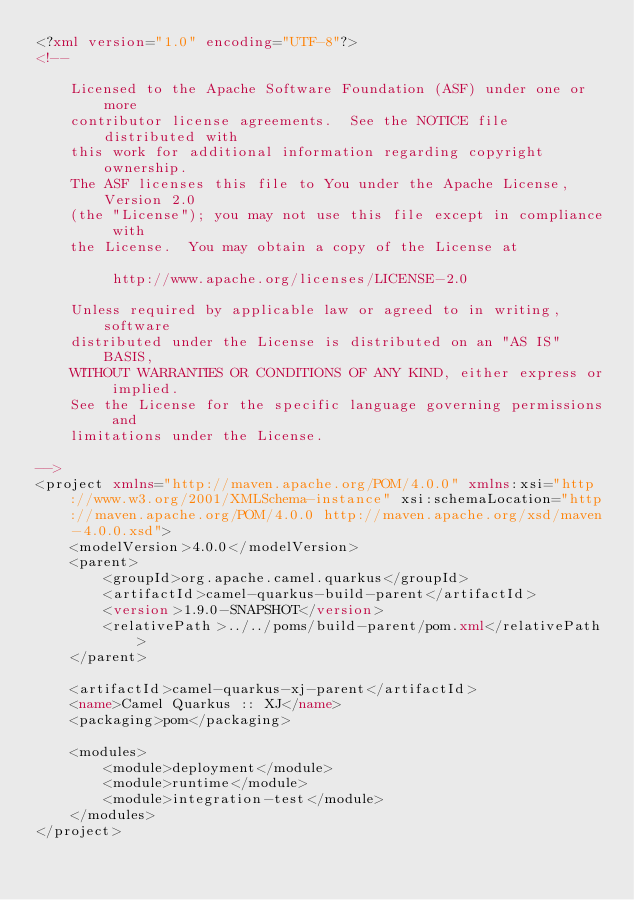Convert code to text. <code><loc_0><loc_0><loc_500><loc_500><_XML_><?xml version="1.0" encoding="UTF-8"?>
<!--

    Licensed to the Apache Software Foundation (ASF) under one or more
    contributor license agreements.  See the NOTICE file distributed with
    this work for additional information regarding copyright ownership.
    The ASF licenses this file to You under the Apache License, Version 2.0
    (the "License"); you may not use this file except in compliance with
    the License.  You may obtain a copy of the License at

         http://www.apache.org/licenses/LICENSE-2.0

    Unless required by applicable law or agreed to in writing, software
    distributed under the License is distributed on an "AS IS" BASIS,
    WITHOUT WARRANTIES OR CONDITIONS OF ANY KIND, either express or implied.
    See the License for the specific language governing permissions and
    limitations under the License.

-->
<project xmlns="http://maven.apache.org/POM/4.0.0" xmlns:xsi="http://www.w3.org/2001/XMLSchema-instance" xsi:schemaLocation="http://maven.apache.org/POM/4.0.0 http://maven.apache.org/xsd/maven-4.0.0.xsd">
    <modelVersion>4.0.0</modelVersion>
    <parent>
        <groupId>org.apache.camel.quarkus</groupId>
        <artifactId>camel-quarkus-build-parent</artifactId>
        <version>1.9.0-SNAPSHOT</version>
        <relativePath>../../poms/build-parent/pom.xml</relativePath>
    </parent>

    <artifactId>camel-quarkus-xj-parent</artifactId>
    <name>Camel Quarkus :: XJ</name>
    <packaging>pom</packaging>

    <modules>
        <module>deployment</module>
        <module>runtime</module>
        <module>integration-test</module>
    </modules>
</project>
</code> 